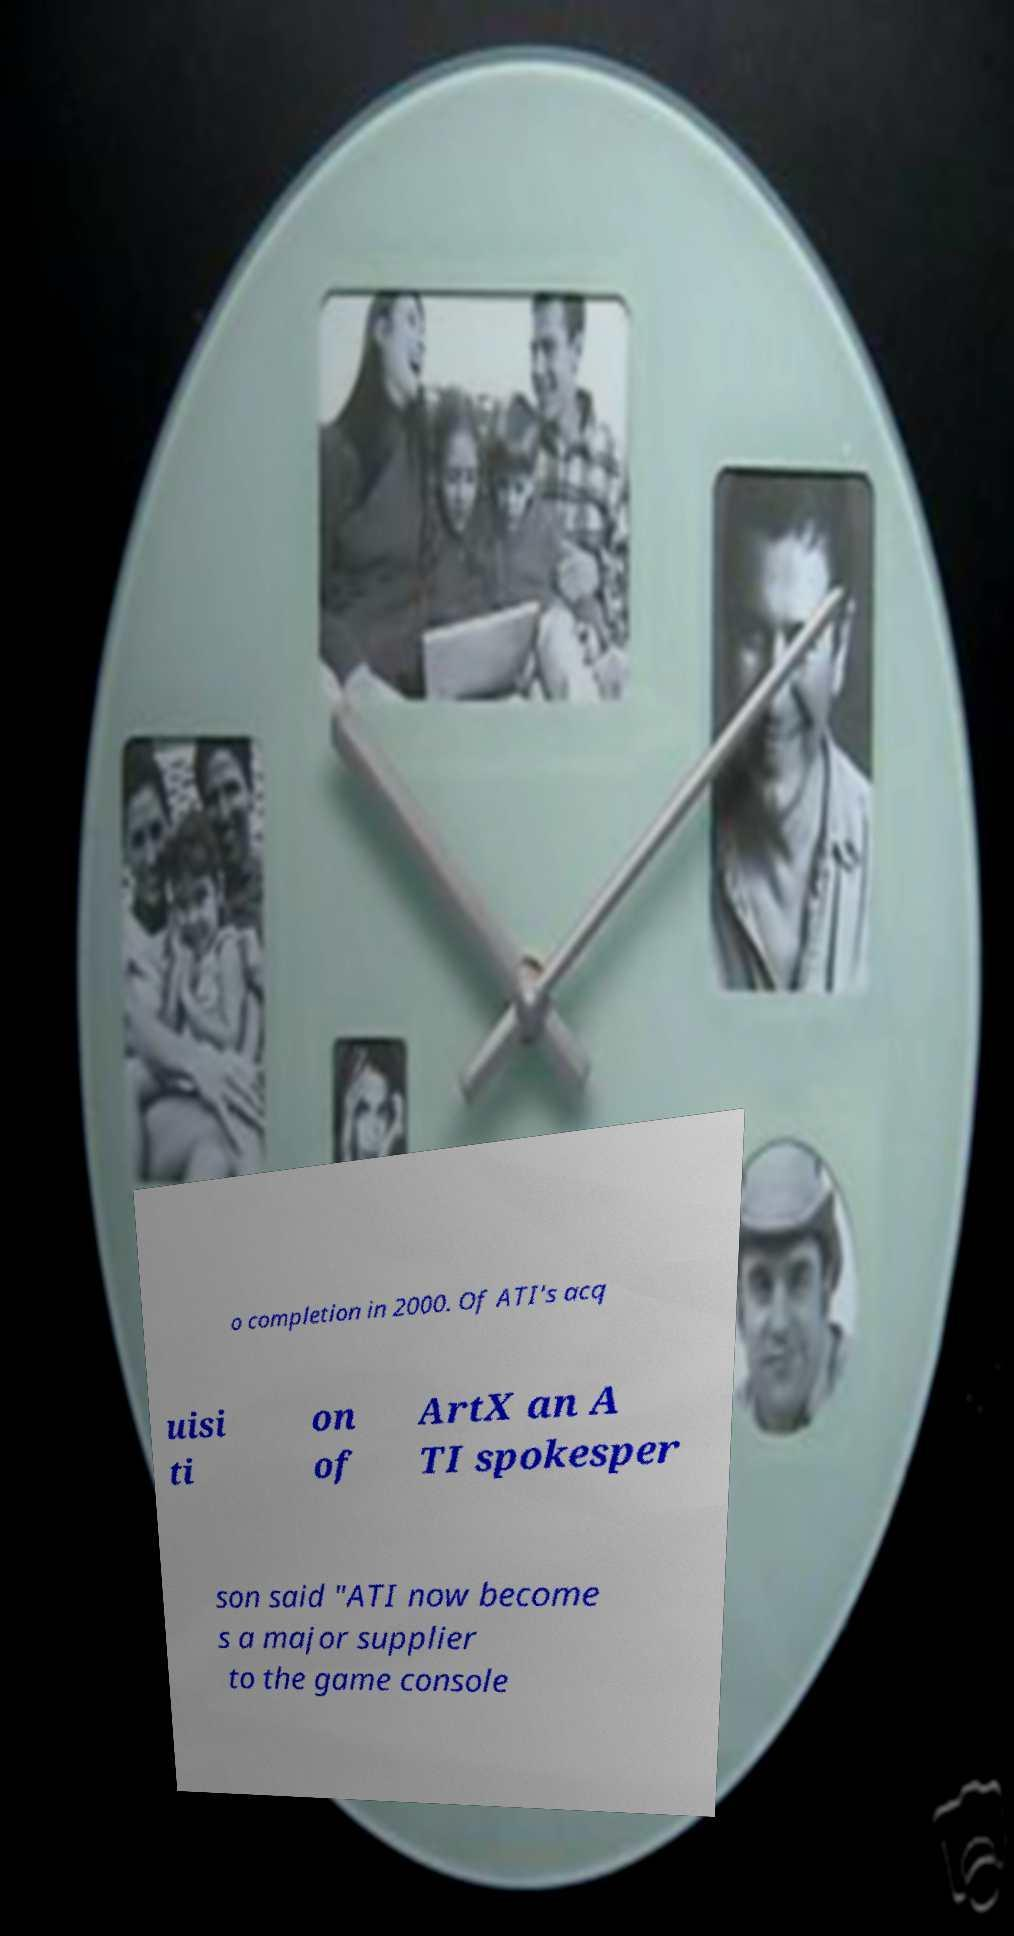There's text embedded in this image that I need extracted. Can you transcribe it verbatim? o completion in 2000. Of ATI's acq uisi ti on of ArtX an A TI spokesper son said "ATI now become s a major supplier to the game console 